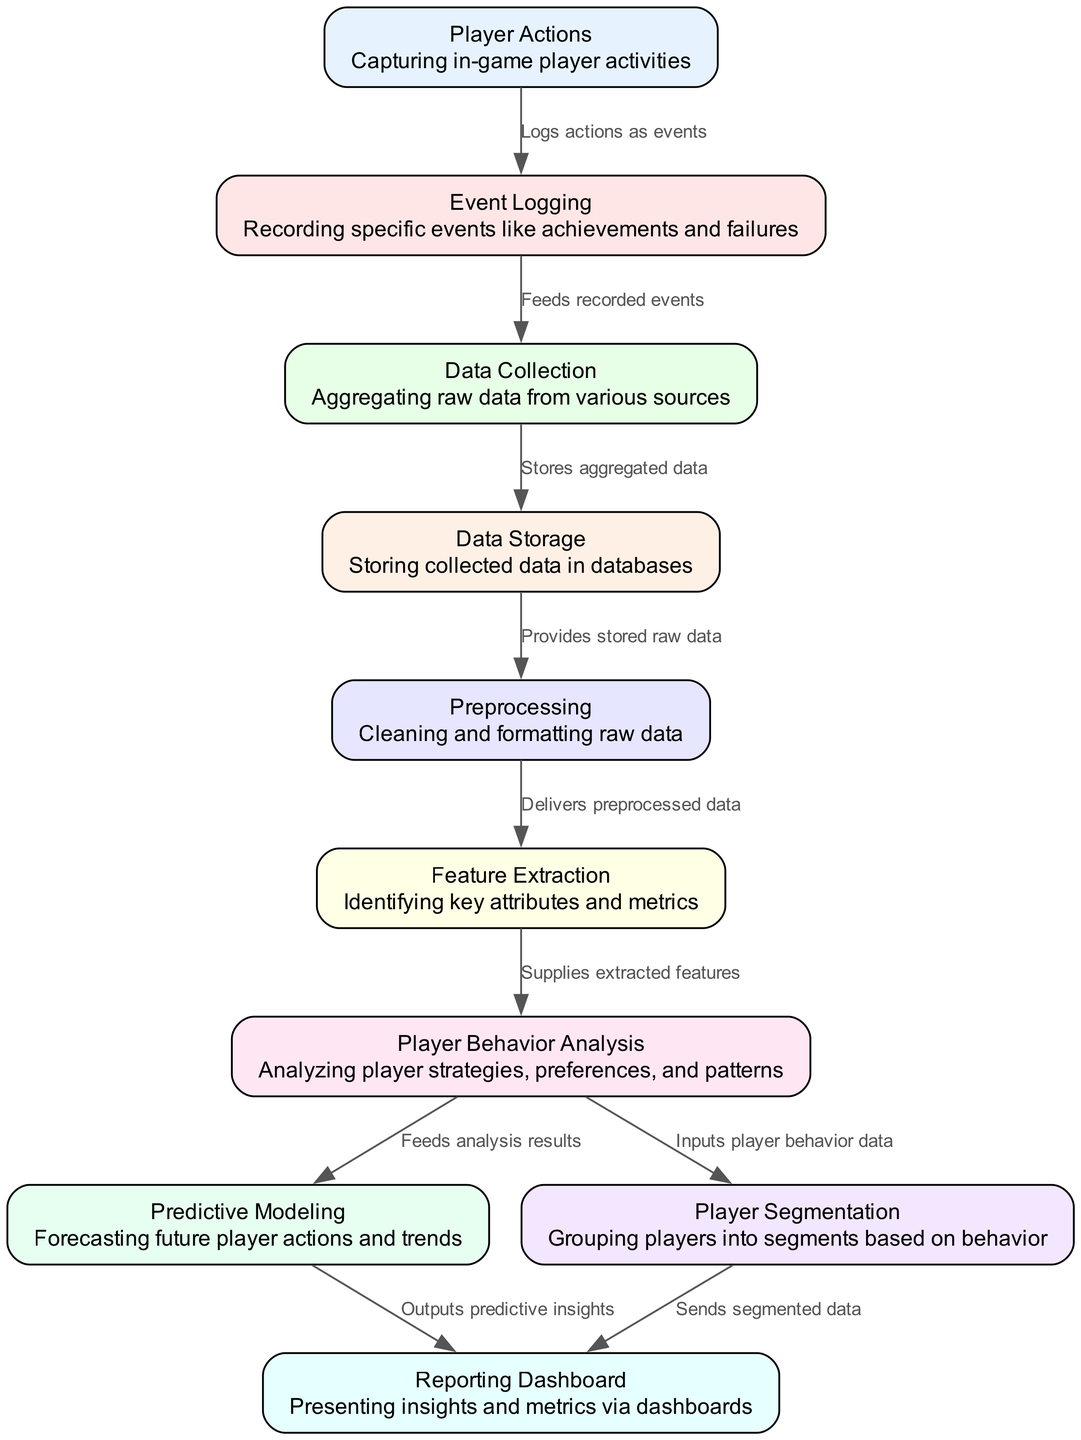What is the first step in the data flow? The first step listed in the diagram is "Player Actions," which captures in-game player activities as the initial process.
Answer: Player Actions How many nodes are there in total? The diagram contains a total of 10 nodes, as outlined in the provided data.
Answer: 10 What does "Event Logging" do? "Event Logging" records specific events like achievements and failures, which helps track player actions effectively.
Answer: Recording specific events like achievements and failures Which node is responsible for storing collected data? The "Data Storage" node is tasked with storing the aggregated data that has been collected from the various sources, facilitating further analysis.
Answer: Data Storage What inputs does "Predictive Modeling" receive? "Predictive Modeling" receives inputs from "Player Behavior Analysis," which provides analysis results concerning player strategies and patterns.
Answer: Player Behavior Analysis Which nodes contribute to the "Reporting Dashboard"? The "Reporting Dashboard" receives outputs from both "Predictive Modeling," which provides predictive insights, and "Player Segmentation," which sends segmented data, combining insights from player behavior and predictions.
Answer: Predictive Modeling and Player Segmentation What is the purpose of "Feature Extraction"? The purpose of "Feature Extraction" is to identify key attributes and metrics from the preprocessed data, which are crucial for further analysis and modeling.
Answer: Identifying key attributes and metrics Which node directly follows "Preprocessing"? Following "Preprocessing," the next node is "Feature Extraction," which utilizes the cleaned and formatted data to extract relevant features.
Answer: Feature Extraction How does "Player Segmentation" utilize data? "Player Segmentation" utilizes data from "Player Behavior Analysis," grouping players into segments based on their observed behaviors and preferences.
Answer: Grouping players into segments based on behavior 